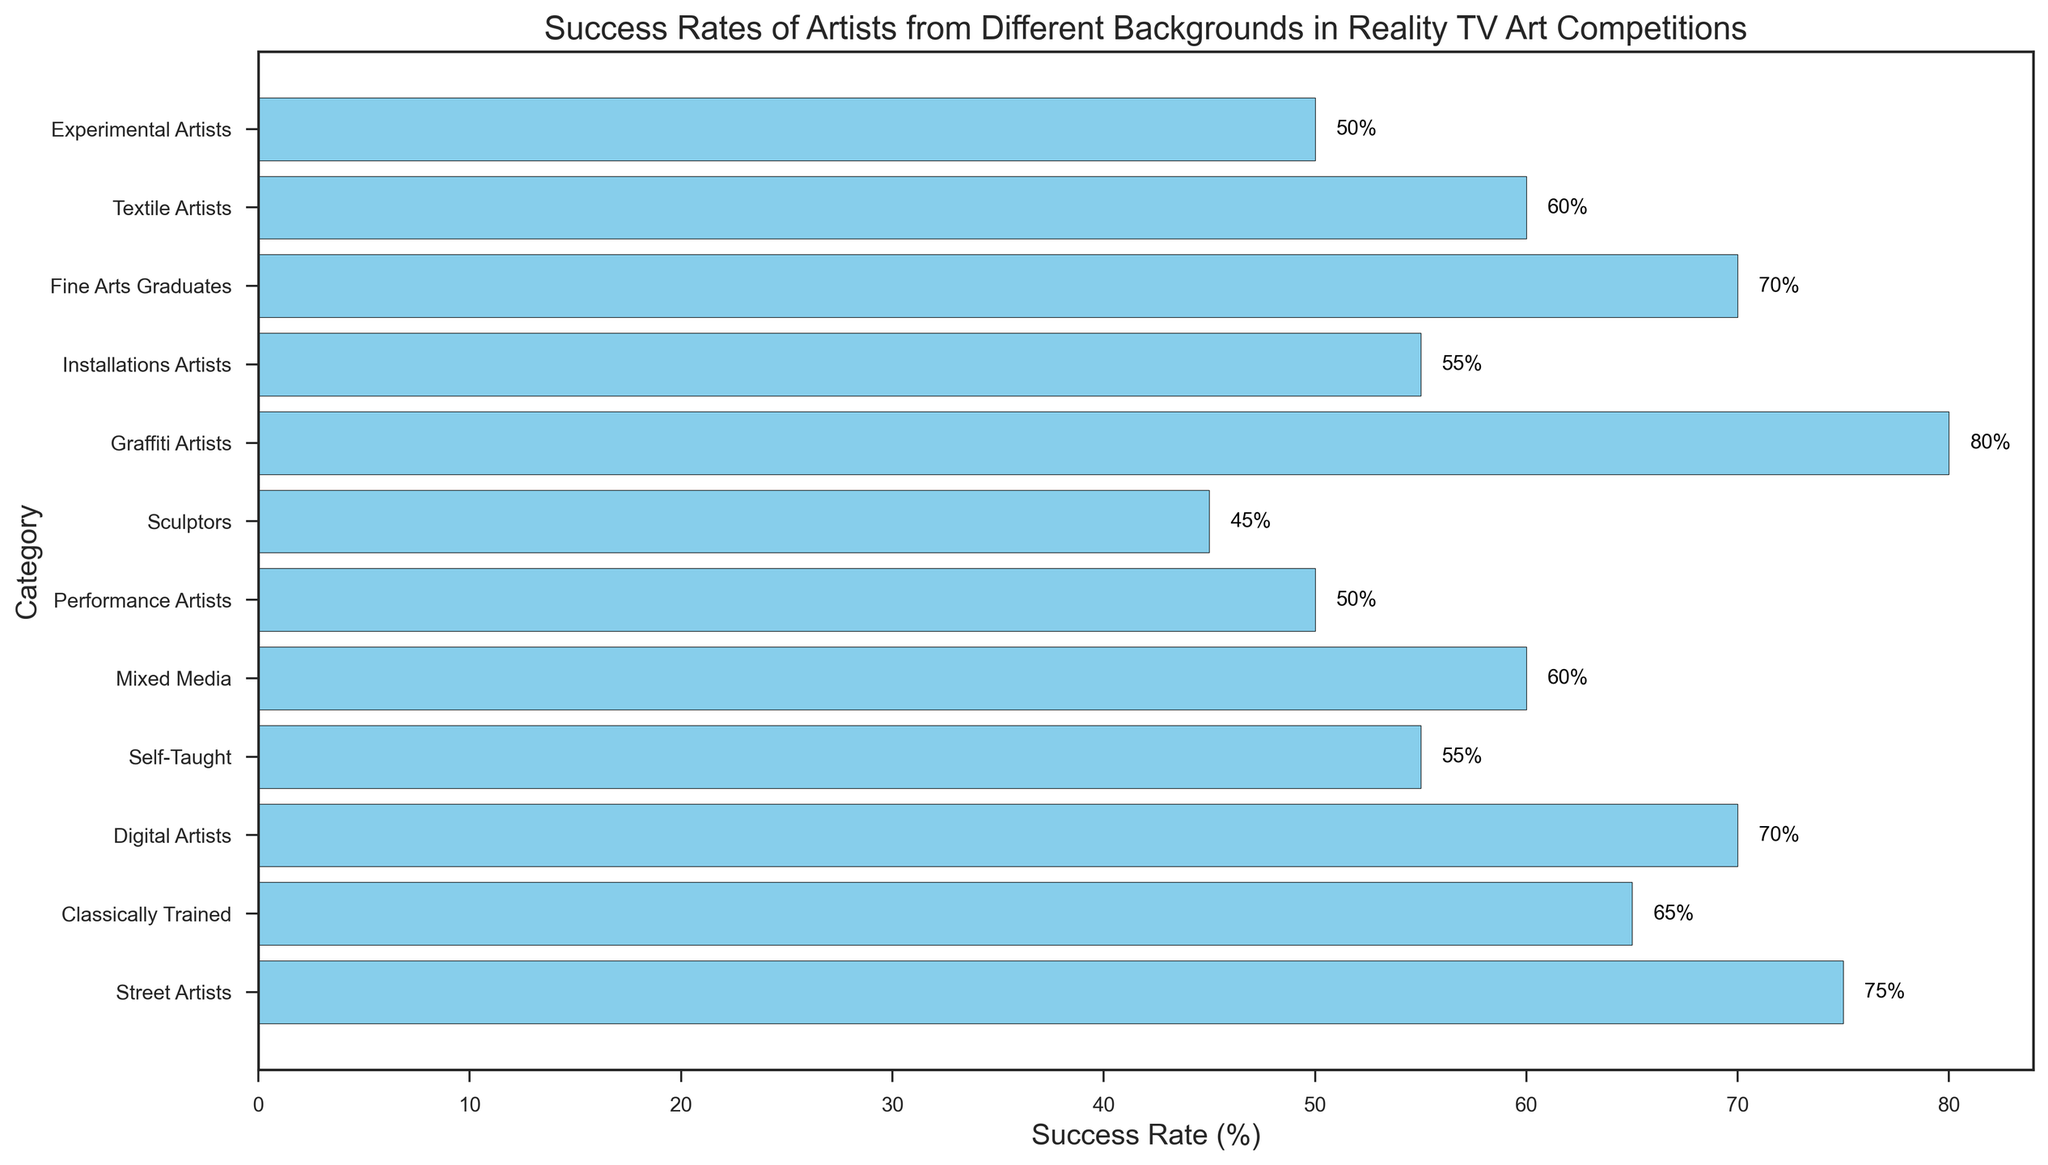What are the success rates of Fine Arts Graduates and Graffiti Artists? The figure shows a bar chart with success rates for various artist categories. Look for the bars labeled Fine Arts Graduates and Graffiti Artists and read the associated percentage values.
Answer: 70%, 80% Which artist category has the lowest success rate? Examine the heights of all the bars and identify the shortest one, which indicates the lowest success rate.
Answer: Sculptors What is the difference in success rate between Classically Trained and Performance Artists? Locate the bars for Classically Trained and Performance Artists, note their success rates (65% and 50% respectively), and subtract the smaller value from the larger one. 65% - 50% = 15%
Answer: 15% Which artist category has a success rate of 60%? Scan the figure for the bar that has the label with 60%, then look at its associated category.
Answer: Mixed Media and Textile Artists What is the average success rate of Street Artists, Digital Artists, and Graffiti Artists? Identify the bars for Street Artists, Digital Artists, and Graffiti Artists, sum up their success rates, and divide by the number of categories (3). (75% + 70% + 80%) / 3 = 75%
Answer: 75% Are there more artist categories with a success rate above or below 60%? Count the number of bars with success rates above and below 60% by scanning the figure and comparing the values with 60%.
Answer: Above What is the combined success rate of Self-Taught and Installation Artists? Find the success rates for Self-Taught (55%) and Installation Artists (55%), then add these values together. 55% + 55% = 110%
Answer: 110% How does the success rate of Digital Artists compare to Performance Artists? Compare the lengths of the bars for Digital Artists (70%) and Performance Artists (50%).
Answer: Digital Artists have a higher success rate than Performance Artists What is the range of success rates shown in the figure? Identify the maximum and minimum success rates in the figure (Graffiti Artists at 80% and Sculptors at 45%) and subtract the smallest from the largest. 80% - 45% = 35%
Answer: 35% What is the median success rate of all artist categories? List all the success rates and find the middle value once they are ordered. Success Rates in ascending order are: 45, 50, 50, 55, 55, 60, 60, 65, 70, 70, 75, 80. The median is the average of 6th and 7th values: (60 + 60) / 2 = 60%
Answer: 60% 